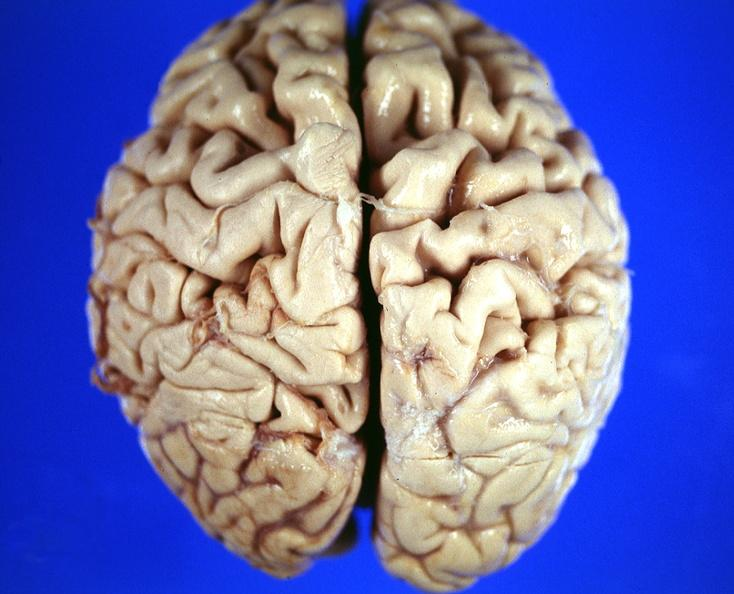does this image show brain, frontal lobe atrophy, pick 's disease?
Answer the question using a single word or phrase. Yes 